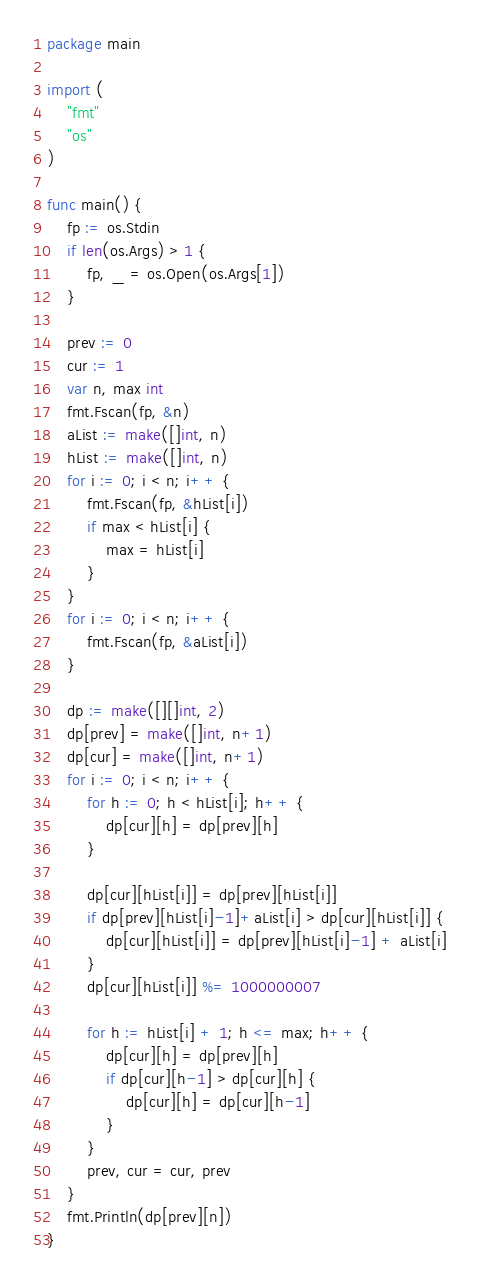Convert code to text. <code><loc_0><loc_0><loc_500><loc_500><_Go_>package main

import (
	"fmt"
	"os"
)

func main() {
	fp := os.Stdin
	if len(os.Args) > 1 {
		fp, _ = os.Open(os.Args[1])
	}

	prev := 0
	cur := 1
	var n, max int
	fmt.Fscan(fp, &n)
	aList := make([]int, n)
	hList := make([]int, n)
	for i := 0; i < n; i++ {
		fmt.Fscan(fp, &hList[i])
		if max < hList[i] {
			max = hList[i]
		}
	}
	for i := 0; i < n; i++ {
		fmt.Fscan(fp, &aList[i])
	}

	dp := make([][]int, 2)
	dp[prev] = make([]int, n+1)
	dp[cur] = make([]int, n+1)
	for i := 0; i < n; i++ {
		for h := 0; h < hList[i]; h++ {
			dp[cur][h] = dp[prev][h]
		}

		dp[cur][hList[i]] = dp[prev][hList[i]]
		if dp[prev][hList[i]-1]+aList[i] > dp[cur][hList[i]] {
			dp[cur][hList[i]] = dp[prev][hList[i]-1] + aList[i]
		}
		dp[cur][hList[i]] %= 1000000007

		for h := hList[i] + 1; h <= max; h++ {
			dp[cur][h] = dp[prev][h]
			if dp[cur][h-1] > dp[cur][h] {
				dp[cur][h] = dp[cur][h-1]
			}
		}
		prev, cur = cur, prev
	}
	fmt.Println(dp[prev][n])
}
</code> 